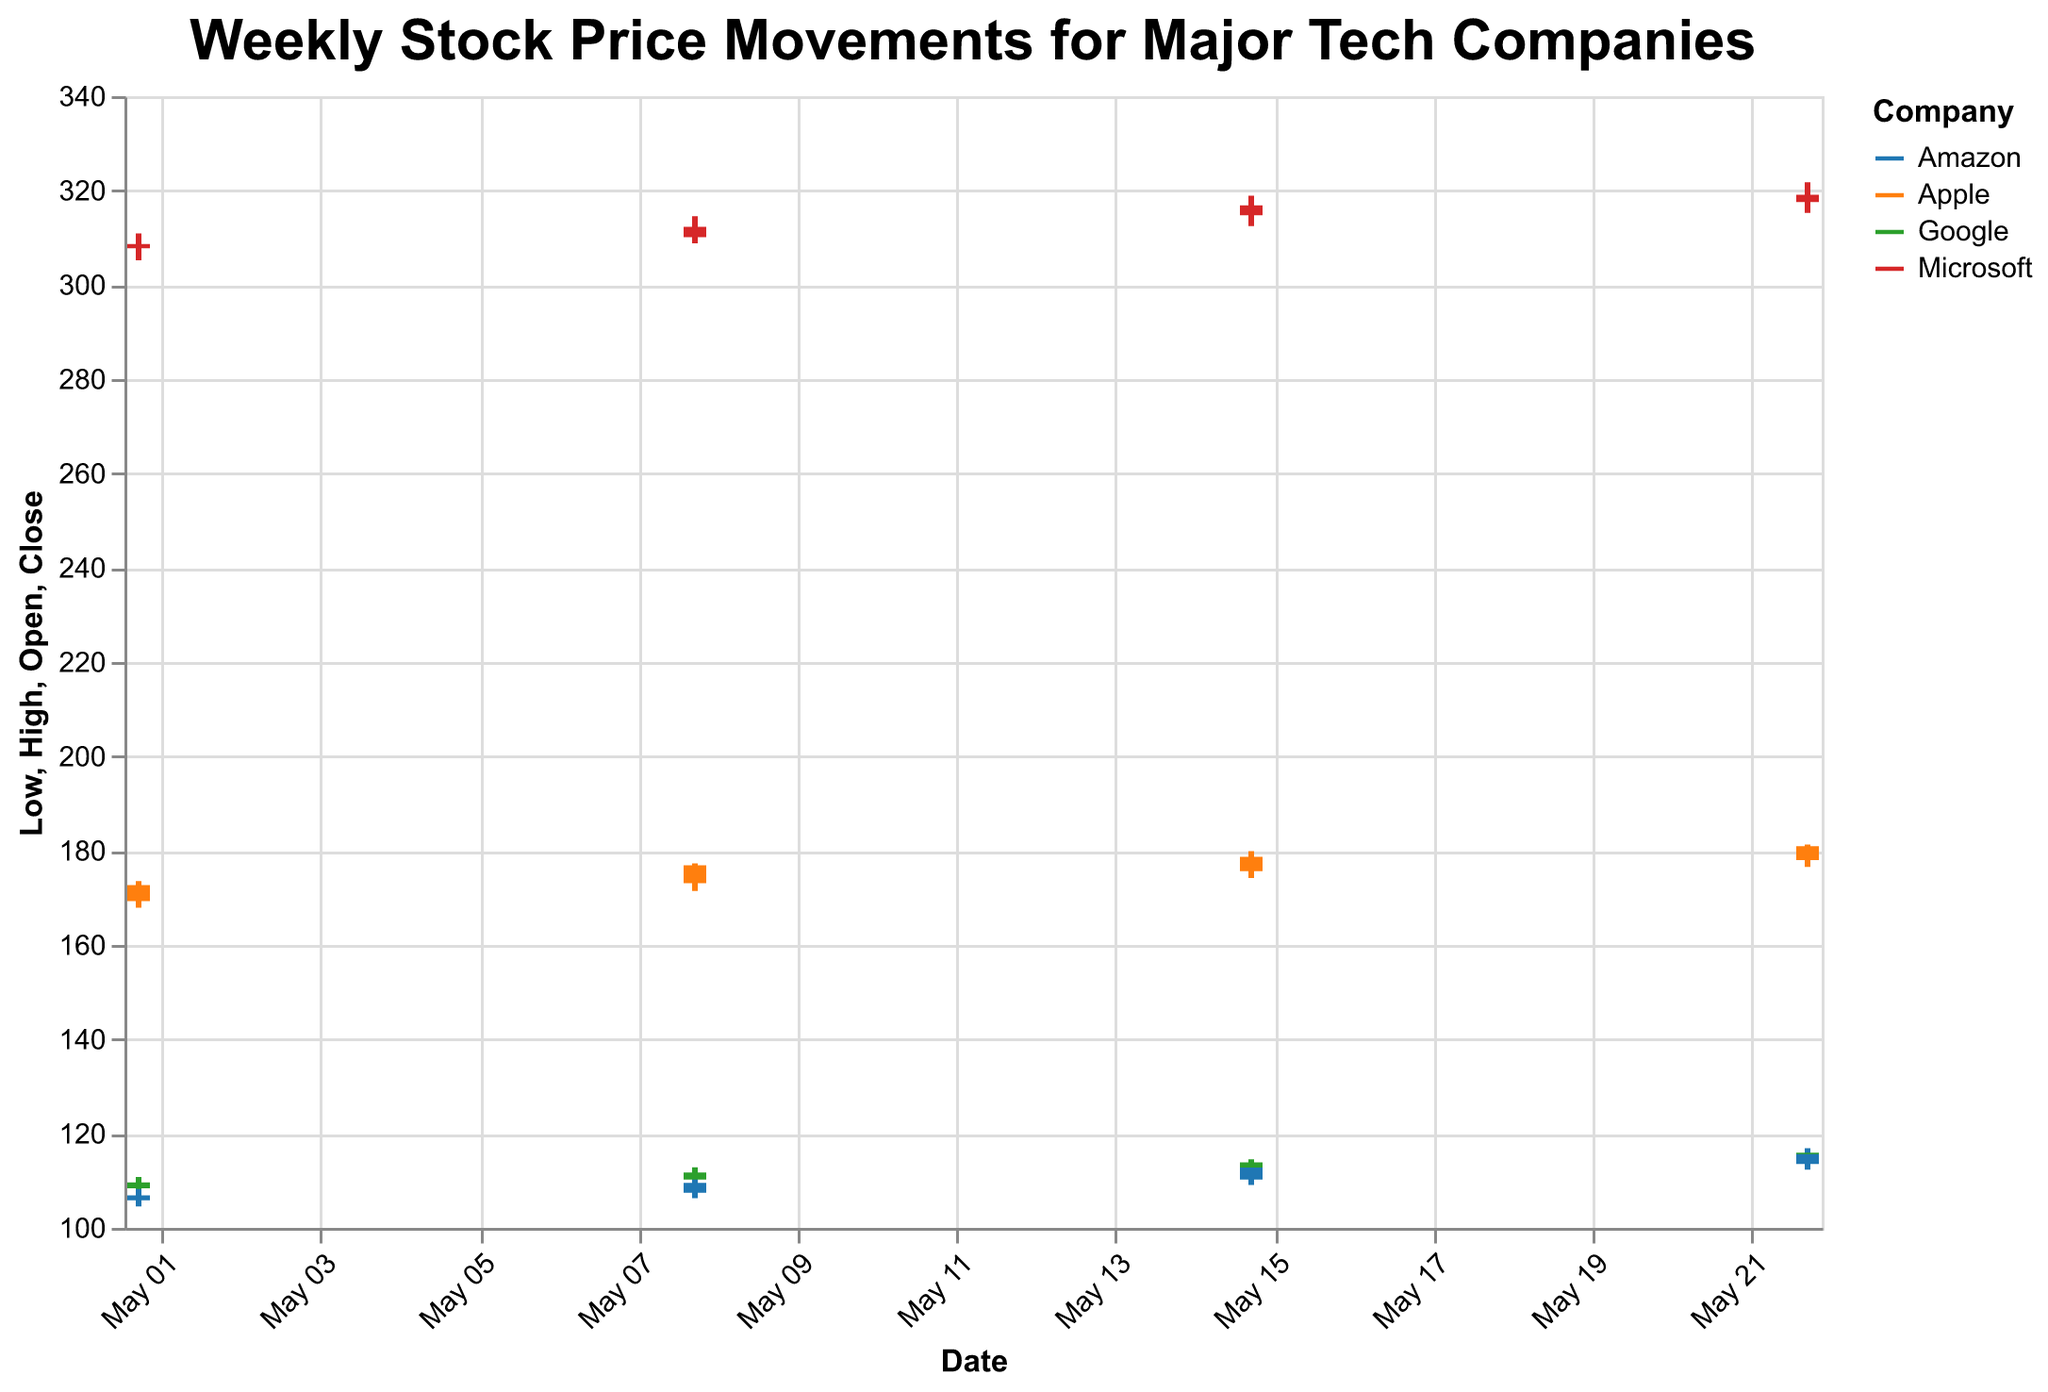What's the highest closing price for Apple during the given weeks? By looking at the "Close" values for Apple across all four weeks, we find the highest value. Week dates and their corresponding closing prices for Apple are: 2023-05-01 (172.69), 2023-05-08 (176.89), 2023-05-15 (178.72), and 2023-05-22 (180.95). The highest is 180.95.
Answer: 180.95 Which company had the highest closing price on 2023-05-08? For 2023-05-08, the closing prices for the companies are: Apple (176.89), Microsoft (312.31), Google (111.75), and Amazon (109.54). Comparing these values, Microsoft had the highest closing price.
Answer: Microsoft What's the average opening price for Google over the four weeks? Google's opening prices over the four weeks are: 108.42, 110.23, 112.34, and 114.12. Summing these gives 108.42 + 110.23 + 112.34 + 114.12 = 445.11. The average is 445.11 / 4 = 111.28.
Answer: 111.28 Did Amazon's closing price increase from 2023-05-01 to 2023-05-22? Amazon's closing prices on these dates are 106.92 (2023-05-01) and 115.67 (2023-05-22). Since 115.67 > 106.92, it increased.
Answer: Yes, it increased Which company had the smallest difference between its highest and lowest prices during the week of 2023-05-15? For 2023-05-15, we calculate the differences (High - Low). Apple: 179.88 - 174.21 = 5.67, Microsoft: 318.92 - 312.45 = 6.47, Google: 114.56 - 111.23 = 3.33, Amazon: 113.45 - 109.12 = 4.33. The smallest difference is 3.33 for Google.
Answer: Google What was the maximum value reached by Microsoft over the entire period? The highest values for Microsoft across the weeks are: 310.89 (2023-05-01), 314.56 (2023-05-08), 318.92 (2023-05-15), and 321.76 (2023-05-22). The highest among these is 321.76.
Answer: 321.76 Did any company's closing price remain unchanged for any week? Comparing the "Close" values for each company week-by-week, we observe that no company's closing price remained unchanged across any weeks.
Answer: No Between Apple and Amazon, which had the greater range in their stock prices for the week of 2023-05-08? For 2023-05-08, Apple's range is 177.32 - 171.45 = 5.87, and Amazon's range is 110.68 - 106.32 = 4.36. Apple had the greater range.
Answer: Apple 